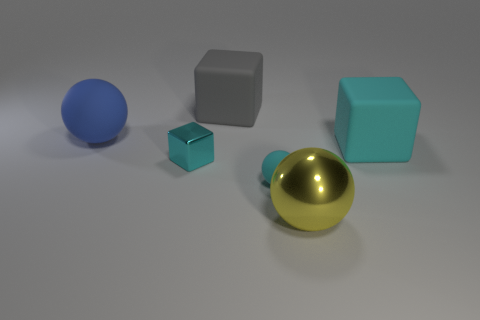Does the blue object have the same shape as the small shiny object?
Offer a terse response. No. What number of things are balls that are in front of the small cyan shiny thing or big shiny objects?
Offer a very short reply. 2. There is a blue thing that is the same material as the big gray block; what is its size?
Provide a short and direct response. Large. What number of rubber blocks have the same color as the small matte thing?
Provide a succinct answer. 1. What number of tiny things are either gray things or rubber cubes?
Offer a very short reply. 0. There is a rubber block that is the same color as the tiny rubber sphere; what size is it?
Make the answer very short. Large. Is there a tiny gray ball that has the same material as the big gray thing?
Give a very brief answer. No. There is a big cube in front of the gray object; what is it made of?
Provide a succinct answer. Rubber. There is a large ball that is left of the shiny sphere; does it have the same color as the large sphere that is in front of the large cyan block?
Your response must be concise. No. There is a metallic thing that is the same size as the gray rubber cube; what color is it?
Your answer should be very brief. Yellow. 